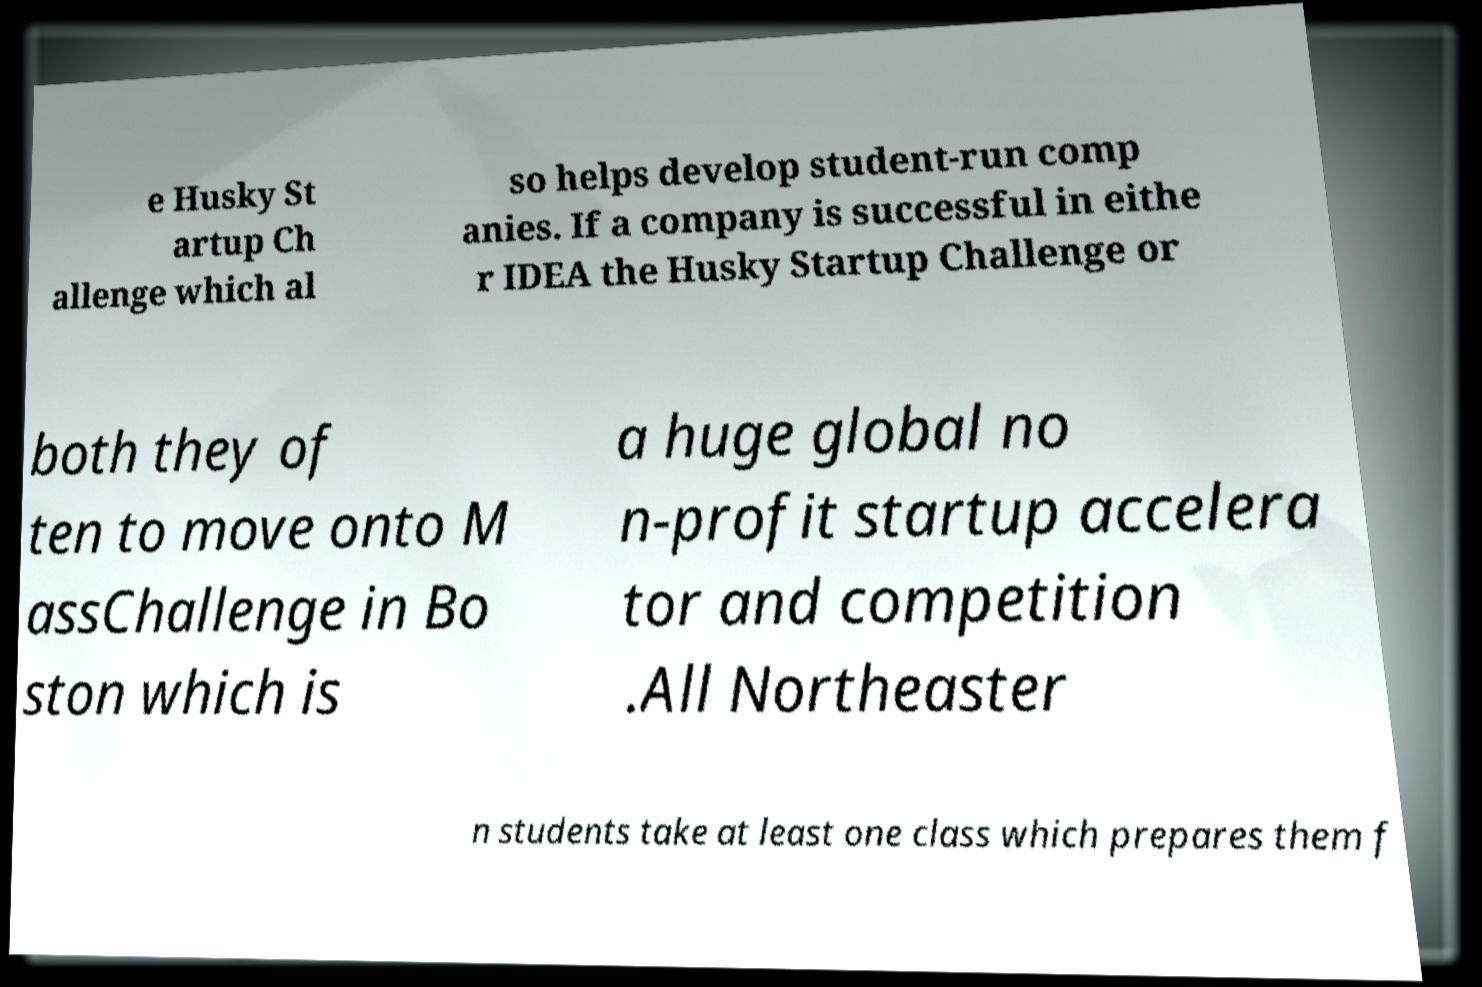Could you assist in decoding the text presented in this image and type it out clearly? e Husky St artup Ch allenge which al so helps develop student-run comp anies. If a company is successful in eithe r IDEA the Husky Startup Challenge or both they of ten to move onto M assChallenge in Bo ston which is a huge global no n-profit startup accelera tor and competition .All Northeaster n students take at least one class which prepares them f 